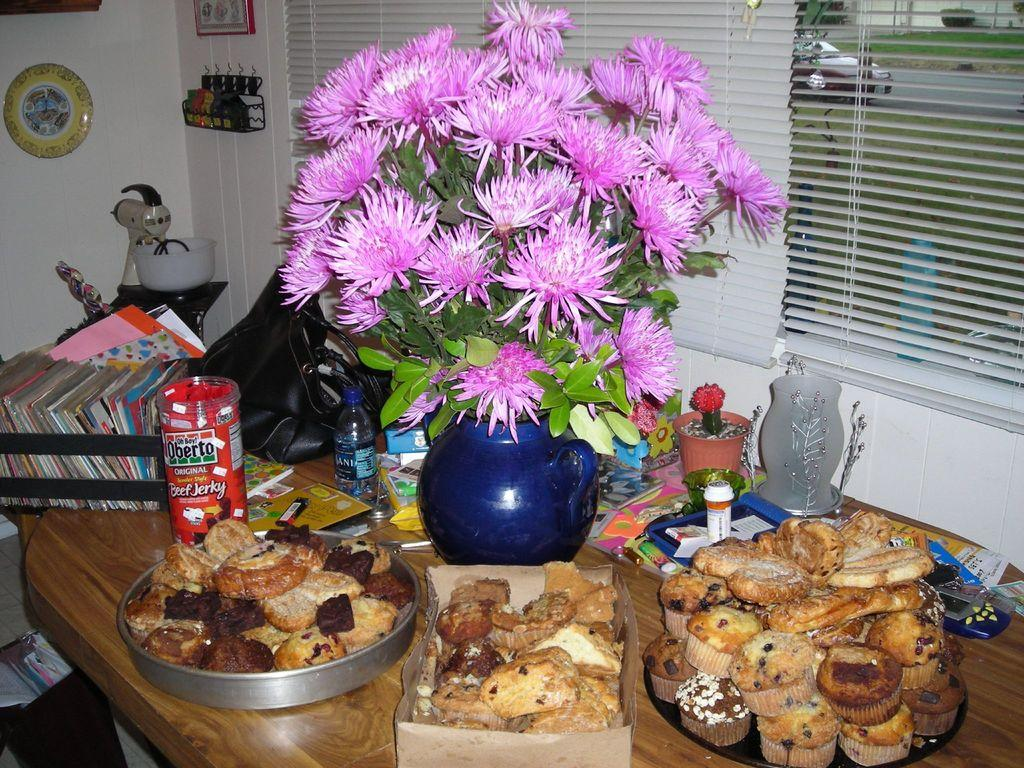What is the main piece of furniture in the image? There is a table in the image. What items can be seen on the table? There are plates, bottles, a flower pot, and dishes on the table. What can be seen in the background of the image? There is a wall and a window in the background of the image. What type of straw is being used by the stranger in the image? There is no stranger present in the image, so it is not possible to determine what type of straw they might be using. 